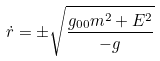Convert formula to latex. <formula><loc_0><loc_0><loc_500><loc_500>\dot { r } = \pm \sqrt { \frac { g _ { 0 0 } m ^ { 2 } + E ^ { 2 } } { - g } }</formula> 